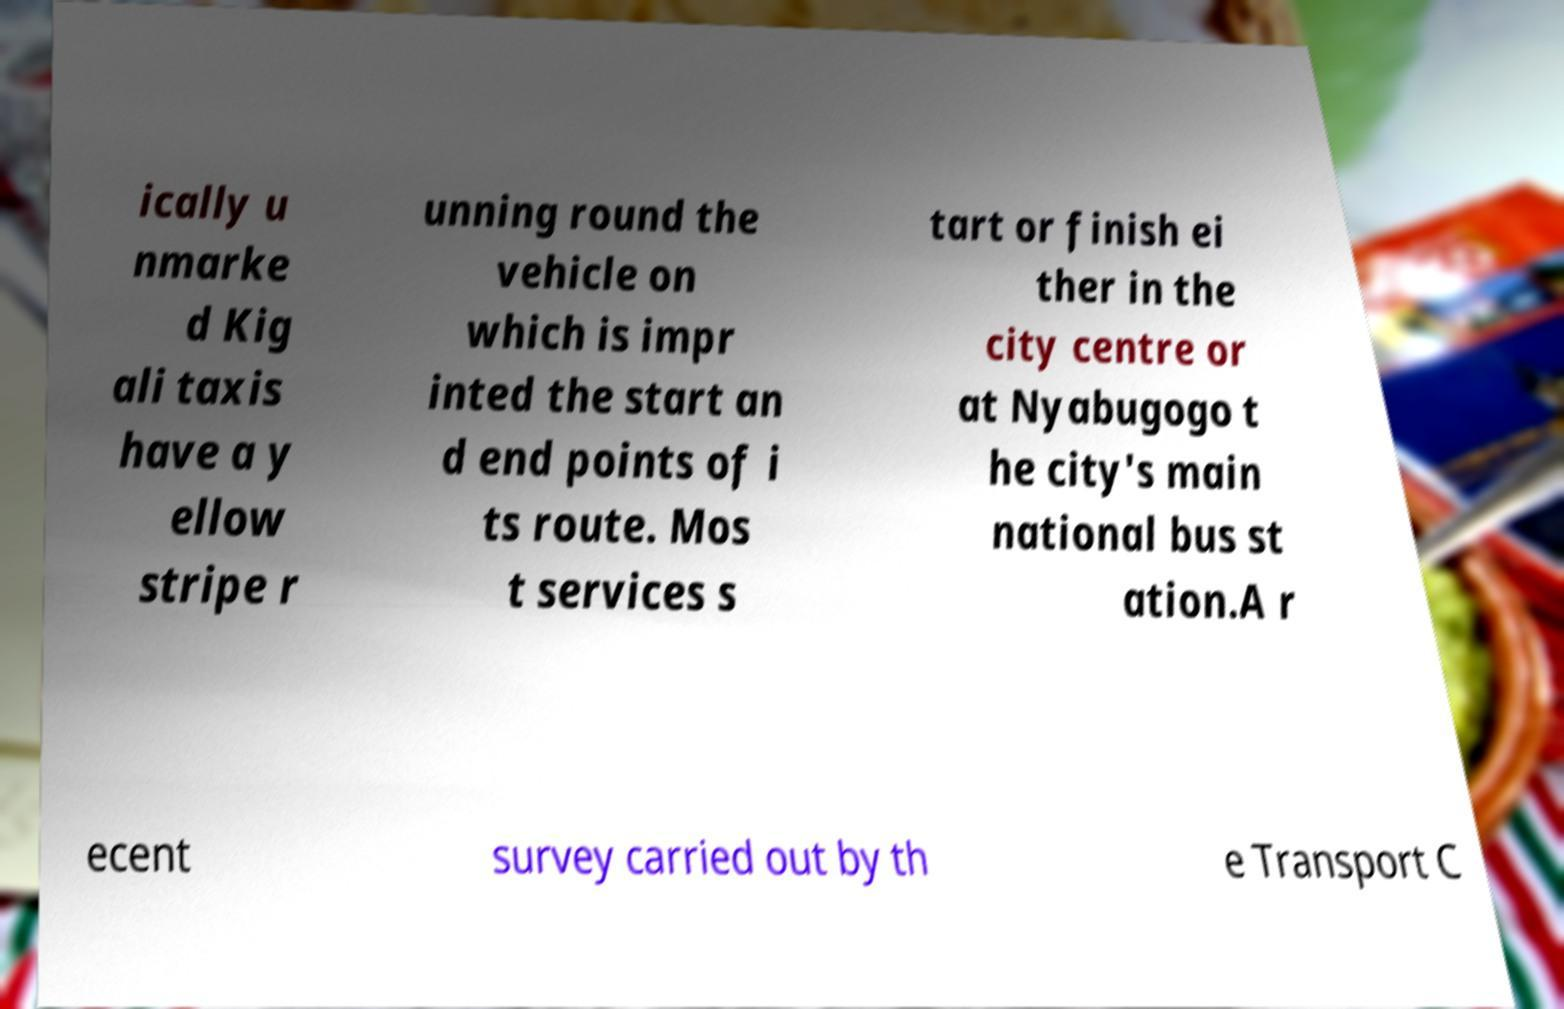Can you read and provide the text displayed in the image?This photo seems to have some interesting text. Can you extract and type it out for me? ically u nmarke d Kig ali taxis have a y ellow stripe r unning round the vehicle on which is impr inted the start an d end points of i ts route. Mos t services s tart or finish ei ther in the city centre or at Nyabugogo t he city's main national bus st ation.A r ecent survey carried out by th e Transport C 